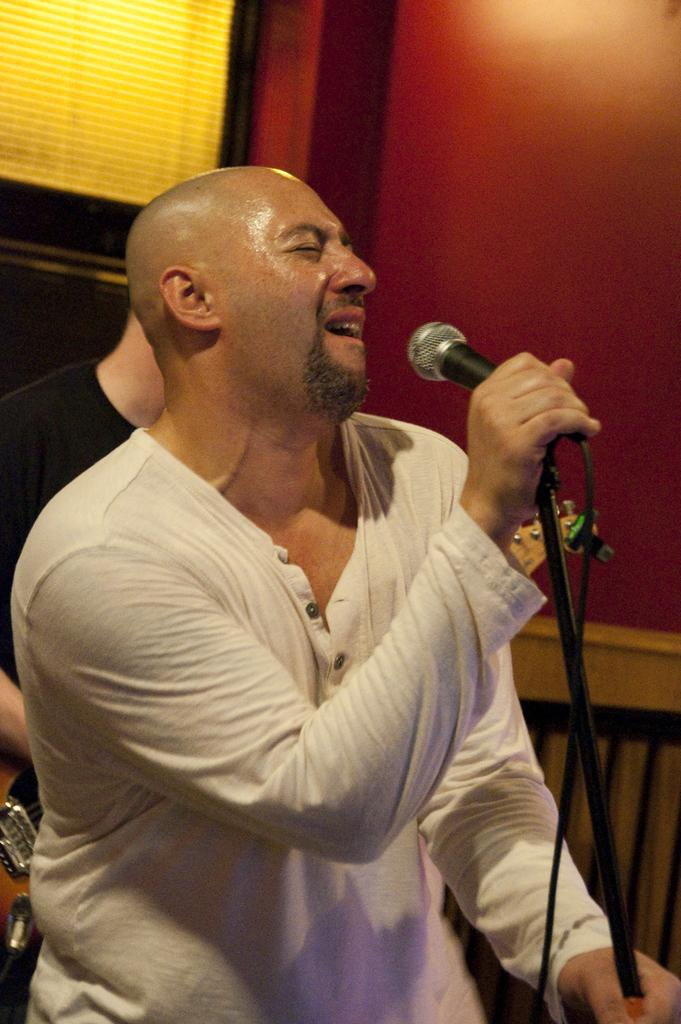What is the man in the image doing? The man is holding a mic in the image. What is the man wearing in the image? The man is wearing a white t-shirt in the image. What can be seen in the background of the image? There is a wall and another person in the background of the image. What is the other person holding in the image? The other person is holding a guitar in the image. What authority does the man have over the noise in the image? There is no mention of authority or noise in the image; it simply shows a man holding a mic and another person holding a guitar. 